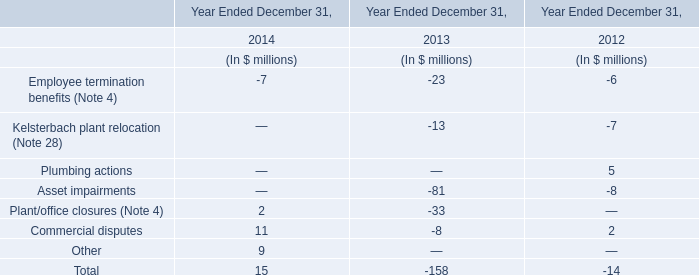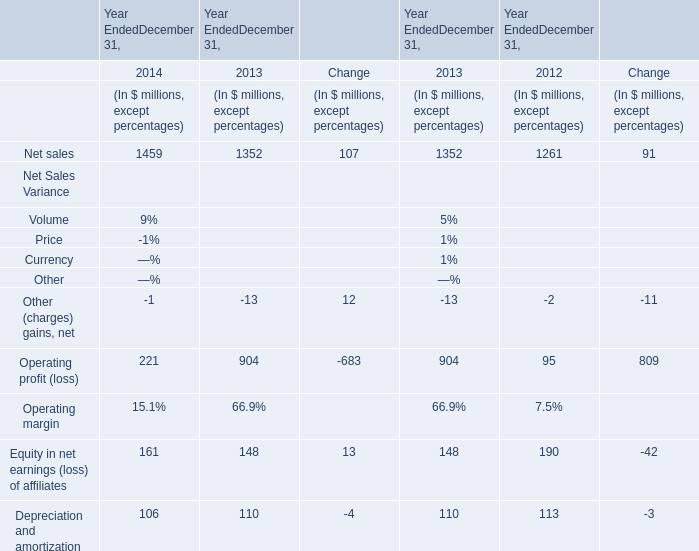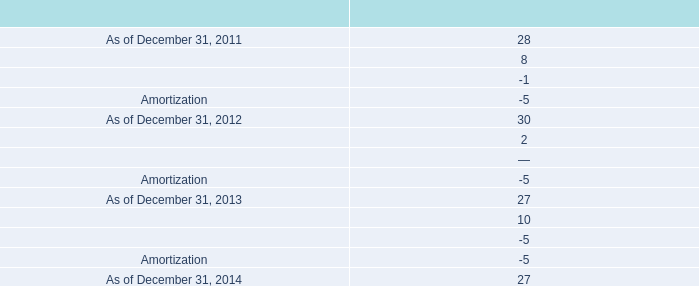how much of the 2013 amortization expense is due to the term c-2 loan facility conversion? 
Computations: (1 / 5)
Answer: 0.2. 